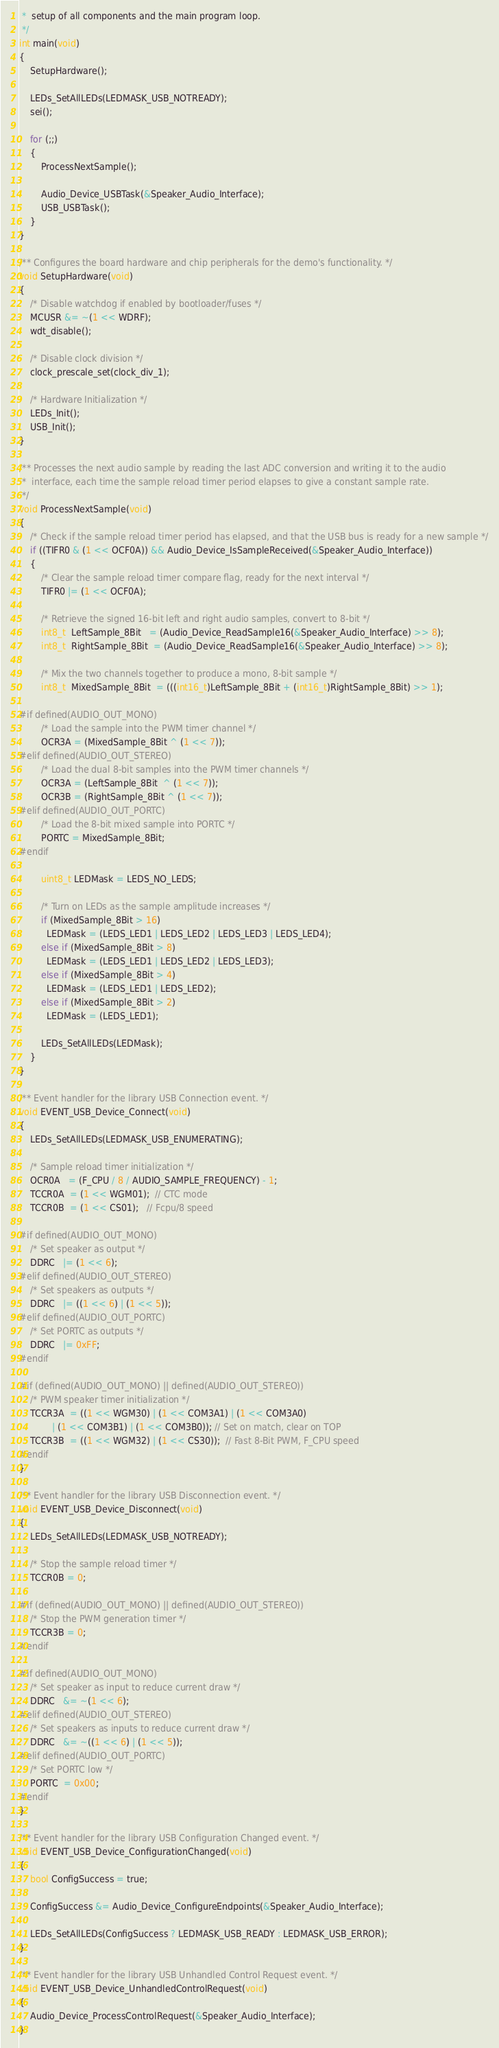Convert code to text. <code><loc_0><loc_0><loc_500><loc_500><_C_> *  setup of all components and the main program loop.
 */
int main(void)
{
	SetupHardware();

	LEDs_SetAllLEDs(LEDMASK_USB_NOTREADY);
	sei();

	for (;;)
	{
		ProcessNextSample();

		Audio_Device_USBTask(&Speaker_Audio_Interface);
		USB_USBTask();
	}
}

/** Configures the board hardware and chip peripherals for the demo's functionality. */
void SetupHardware(void)
{
	/* Disable watchdog if enabled by bootloader/fuses */
	MCUSR &= ~(1 << WDRF);
	wdt_disable();

	/* Disable clock division */
	clock_prescale_set(clock_div_1);

	/* Hardware Initialization */
	LEDs_Init();
	USB_Init();
}

/** Processes the next audio sample by reading the last ADC conversion and writing it to the audio
 *  interface, each time the sample reload timer period elapses to give a constant sample rate.
 */
void ProcessNextSample(void)
{
	/* Check if the sample reload timer period has elapsed, and that the USB bus is ready for a new sample */
	if ((TIFR0 & (1 << OCF0A)) && Audio_Device_IsSampleReceived(&Speaker_Audio_Interface))
	{
		/* Clear the sample reload timer compare flag, ready for the next interval */
		TIFR0 |= (1 << OCF0A);

		/* Retrieve the signed 16-bit left and right audio samples, convert to 8-bit */
		int8_t  LeftSample_8Bit   = (Audio_Device_ReadSample16(&Speaker_Audio_Interface) >> 8);
		int8_t  RightSample_8Bit  = (Audio_Device_ReadSample16(&Speaker_Audio_Interface) >> 8);

		/* Mix the two channels together to produce a mono, 8-bit sample */
		int8_t  MixedSample_8Bit  = (((int16_t)LeftSample_8Bit + (int16_t)RightSample_8Bit) >> 1);

#if defined(AUDIO_OUT_MONO)
		/* Load the sample into the PWM timer channel */
		OCR3A = (MixedSample_8Bit ^ (1 << 7));
#elif defined(AUDIO_OUT_STEREO)
		/* Load the dual 8-bit samples into the PWM timer channels */
		OCR3A = (LeftSample_8Bit  ^ (1 << 7));
		OCR3B = (RightSample_8Bit ^ (1 << 7));
#elif defined(AUDIO_OUT_PORTC)
		/* Load the 8-bit mixed sample into PORTC */
		PORTC = MixedSample_8Bit;
#endif

		uint8_t LEDMask = LEDS_NO_LEDS;

		/* Turn on LEDs as the sample amplitude increases */
		if (MixedSample_8Bit > 16)
		  LEDMask = (LEDS_LED1 | LEDS_LED2 | LEDS_LED3 | LEDS_LED4);
		else if (MixedSample_8Bit > 8)
		  LEDMask = (LEDS_LED1 | LEDS_LED2 | LEDS_LED3);
		else if (MixedSample_8Bit > 4)
		  LEDMask = (LEDS_LED1 | LEDS_LED2);
		else if (MixedSample_8Bit > 2)
		  LEDMask = (LEDS_LED1);

		LEDs_SetAllLEDs(LEDMask);
	}
}

/** Event handler for the library USB Connection event. */
void EVENT_USB_Device_Connect(void)
{
	LEDs_SetAllLEDs(LEDMASK_USB_ENUMERATING);

	/* Sample reload timer initialization */
	OCR0A   = (F_CPU / 8 / AUDIO_SAMPLE_FREQUENCY) - 1;
	TCCR0A  = (1 << WGM01);  // CTC mode
	TCCR0B  = (1 << CS01);   // Fcpu/8 speed

#if defined(AUDIO_OUT_MONO)
	/* Set speaker as output */
	DDRC   |= (1 << 6);
#elif defined(AUDIO_OUT_STEREO)
	/* Set speakers as outputs */
	DDRC   |= ((1 << 6) | (1 << 5));
#elif defined(AUDIO_OUT_PORTC)
	/* Set PORTC as outputs */
	DDRC   |= 0xFF;
#endif

#if (defined(AUDIO_OUT_MONO) || defined(AUDIO_OUT_STEREO))
	/* PWM speaker timer initialization */
	TCCR3A  = ((1 << WGM30) | (1 << COM3A1) | (1 << COM3A0)
	        | (1 << COM3B1) | (1 << COM3B0)); // Set on match, clear on TOP
	TCCR3B  = ((1 << WGM32) | (1 << CS30));  // Fast 8-Bit PWM, F_CPU speed
#endif
}

/** Event handler for the library USB Disconnection event. */
void EVENT_USB_Device_Disconnect(void)
{
	LEDs_SetAllLEDs(LEDMASK_USB_NOTREADY);

	/* Stop the sample reload timer */
	TCCR0B = 0;

#if (defined(AUDIO_OUT_MONO) || defined(AUDIO_OUT_STEREO))
	/* Stop the PWM generation timer */
	TCCR3B = 0;
#endif

#if defined(AUDIO_OUT_MONO)
	/* Set speaker as input to reduce current draw */
	DDRC   &= ~(1 << 6);
#elif defined(AUDIO_OUT_STEREO)
	/* Set speakers as inputs to reduce current draw */
	DDRC   &= ~((1 << 6) | (1 << 5));
#elif defined(AUDIO_OUT_PORTC)
	/* Set PORTC low */
	PORTC  = 0x00;
#endif
}

/** Event handler for the library USB Configuration Changed event. */
void EVENT_USB_Device_ConfigurationChanged(void)
{
	bool ConfigSuccess = true;

	ConfigSuccess &= Audio_Device_ConfigureEndpoints(&Speaker_Audio_Interface);

	LEDs_SetAllLEDs(ConfigSuccess ? LEDMASK_USB_READY : LEDMASK_USB_ERROR);
}

/** Event handler for the library USB Unhandled Control Request event. */
void EVENT_USB_Device_UnhandledControlRequest(void)
{
	Audio_Device_ProcessControlRequest(&Speaker_Audio_Interface);
}

</code> 